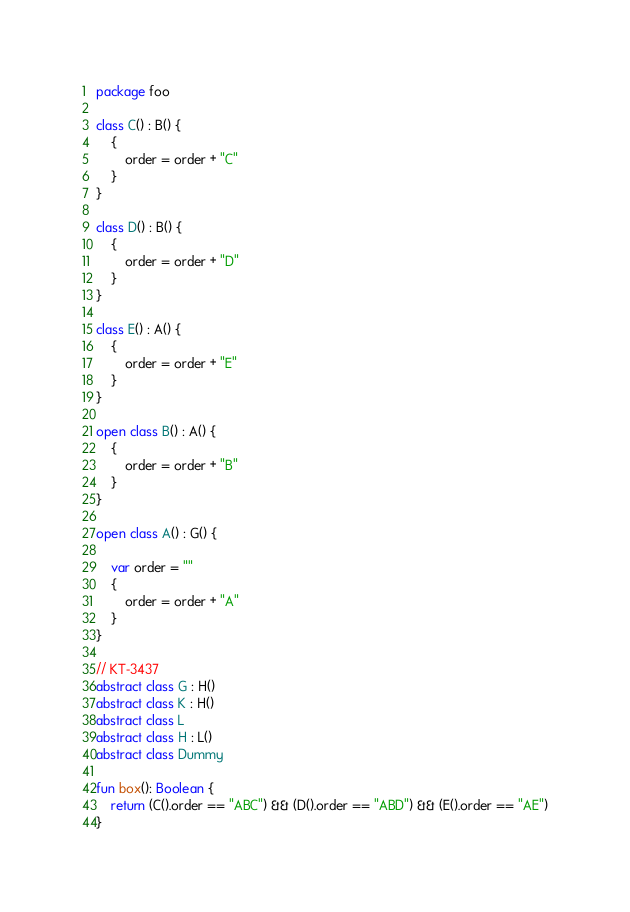<code> <loc_0><loc_0><loc_500><loc_500><_Kotlin_>package foo

class C() : B() {
    {
        order = order + "C"
    }
}

class D() : B() {
    {
        order = order + "D"
    }
}

class E() : A() {
    {
        order = order + "E"
    }
}

open class B() : A() {
    {
        order = order + "B"
    }
}

open class A() : G() {

    var order = ""
    {
        order = order + "A"
    }
}

// KT-3437
abstract class G : H()
abstract class K : H()
abstract class L
abstract class H : L()
abstract class Dummy

fun box(): Boolean {
    return (C().order == "ABC") && (D().order == "ABD") && (E().order == "AE")
}</code> 